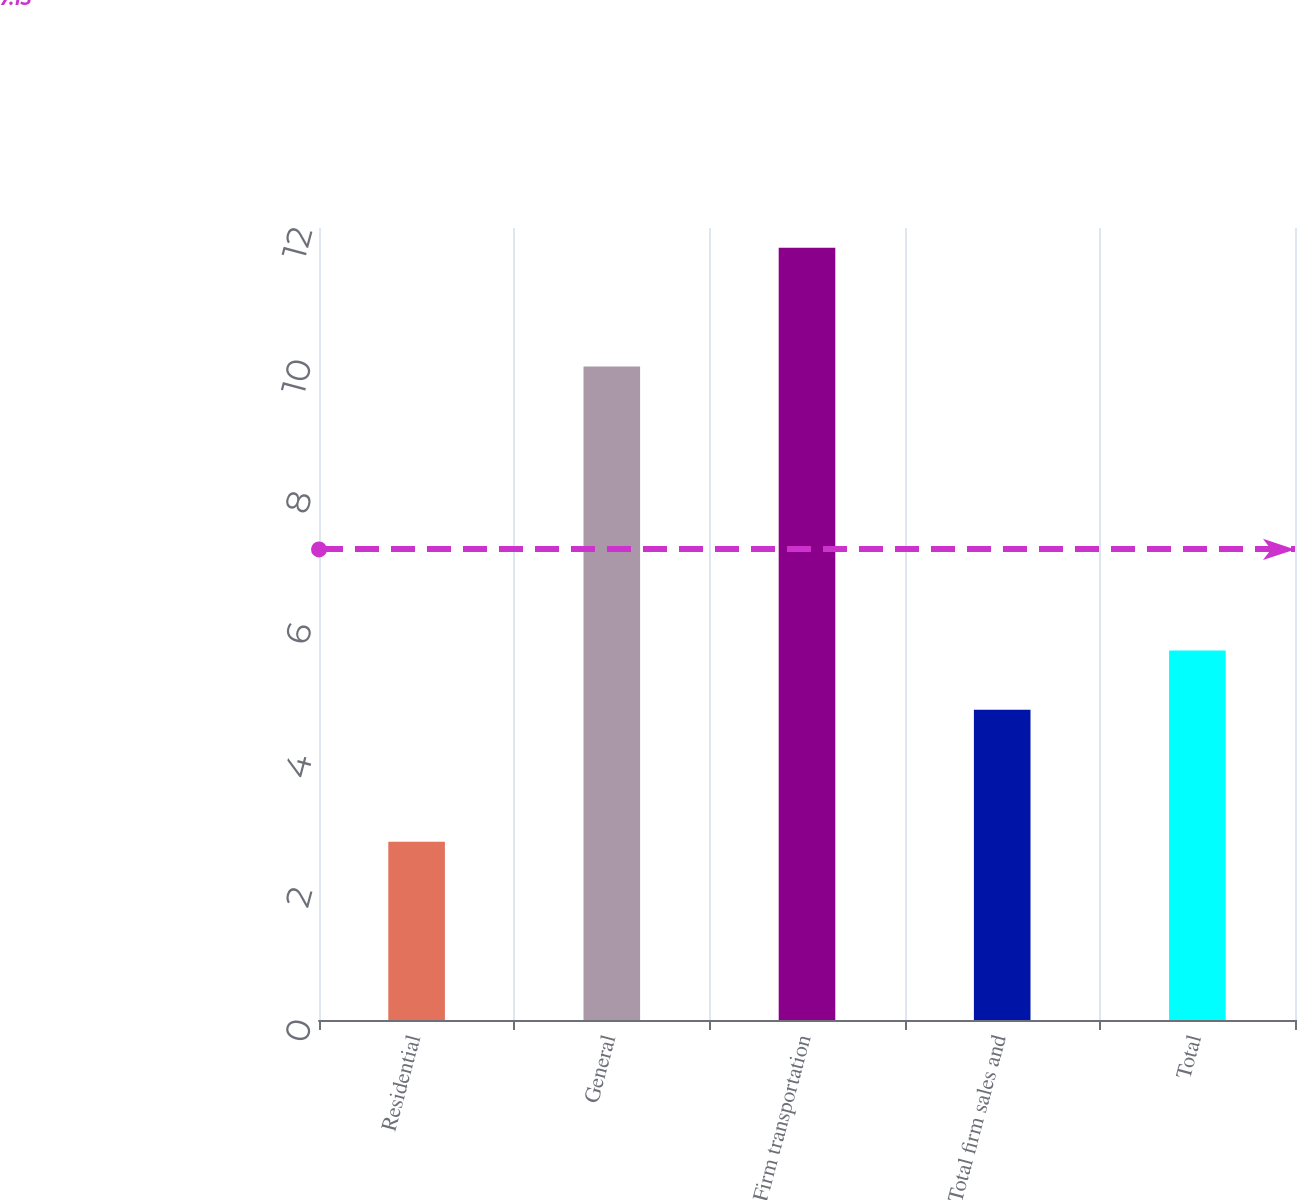Convert chart. <chart><loc_0><loc_0><loc_500><loc_500><bar_chart><fcel>Residential<fcel>General<fcel>Firm transportation<fcel>Total firm sales and<fcel>Total<nl><fcel>2.7<fcel>9.9<fcel>11.7<fcel>4.7<fcel>5.6<nl></chart> 